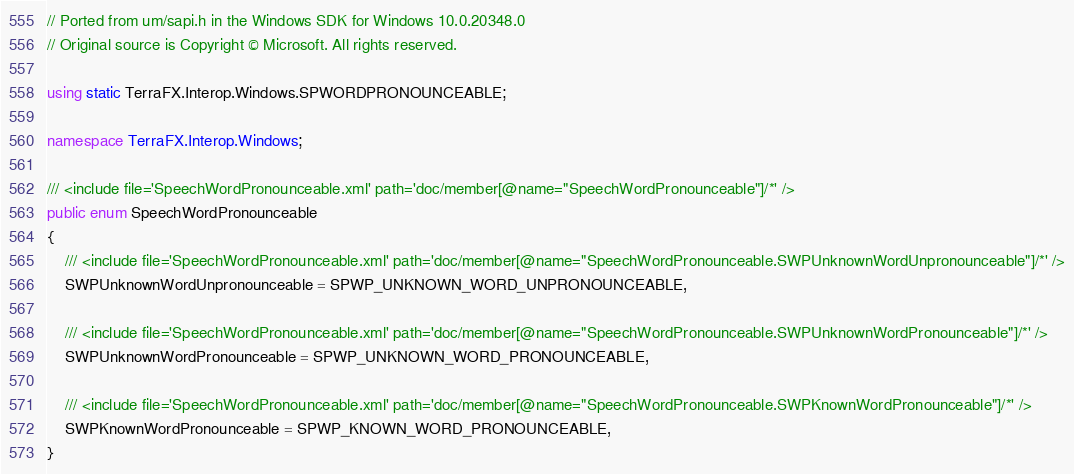<code> <loc_0><loc_0><loc_500><loc_500><_C#_>
// Ported from um/sapi.h in the Windows SDK for Windows 10.0.20348.0
// Original source is Copyright © Microsoft. All rights reserved.

using static TerraFX.Interop.Windows.SPWORDPRONOUNCEABLE;

namespace TerraFX.Interop.Windows;

/// <include file='SpeechWordPronounceable.xml' path='doc/member[@name="SpeechWordPronounceable"]/*' />
public enum SpeechWordPronounceable
{
    /// <include file='SpeechWordPronounceable.xml' path='doc/member[@name="SpeechWordPronounceable.SWPUnknownWordUnpronounceable"]/*' />
    SWPUnknownWordUnpronounceable = SPWP_UNKNOWN_WORD_UNPRONOUNCEABLE,

    /// <include file='SpeechWordPronounceable.xml' path='doc/member[@name="SpeechWordPronounceable.SWPUnknownWordPronounceable"]/*' />
    SWPUnknownWordPronounceable = SPWP_UNKNOWN_WORD_PRONOUNCEABLE,

    /// <include file='SpeechWordPronounceable.xml' path='doc/member[@name="SpeechWordPronounceable.SWPKnownWordPronounceable"]/*' />
    SWPKnownWordPronounceable = SPWP_KNOWN_WORD_PRONOUNCEABLE,
}
</code> 